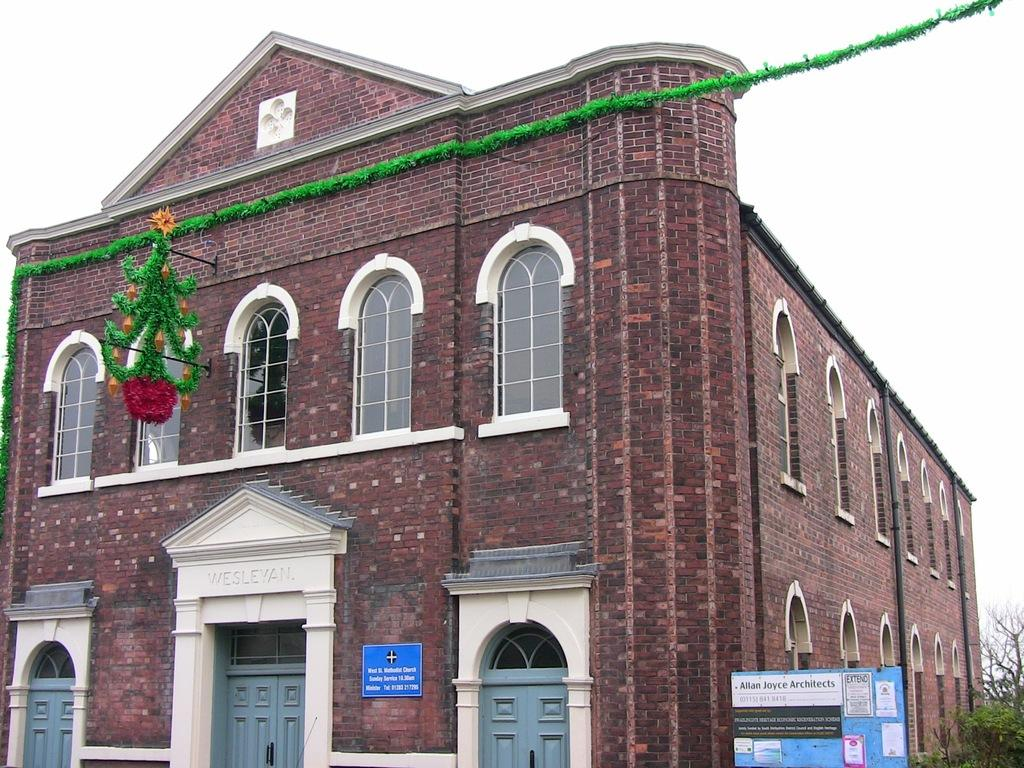What type of structure is visible in the image? There is a building in the image. What material is the building made of? The building is made up of red bricks. Are there any decorations on the building? Yes, the building is decorated with green color paper lace. What can be seen behind the building? There are trees behind the building. Is the building located inside a cave in the image? No, the building is not located inside a cave; it is a standalone structure. Is the area around the building particularly quiet in the image? The provided facts do not give any information about the noise level in the image, so we cannot determine if the area is quiet or not. 